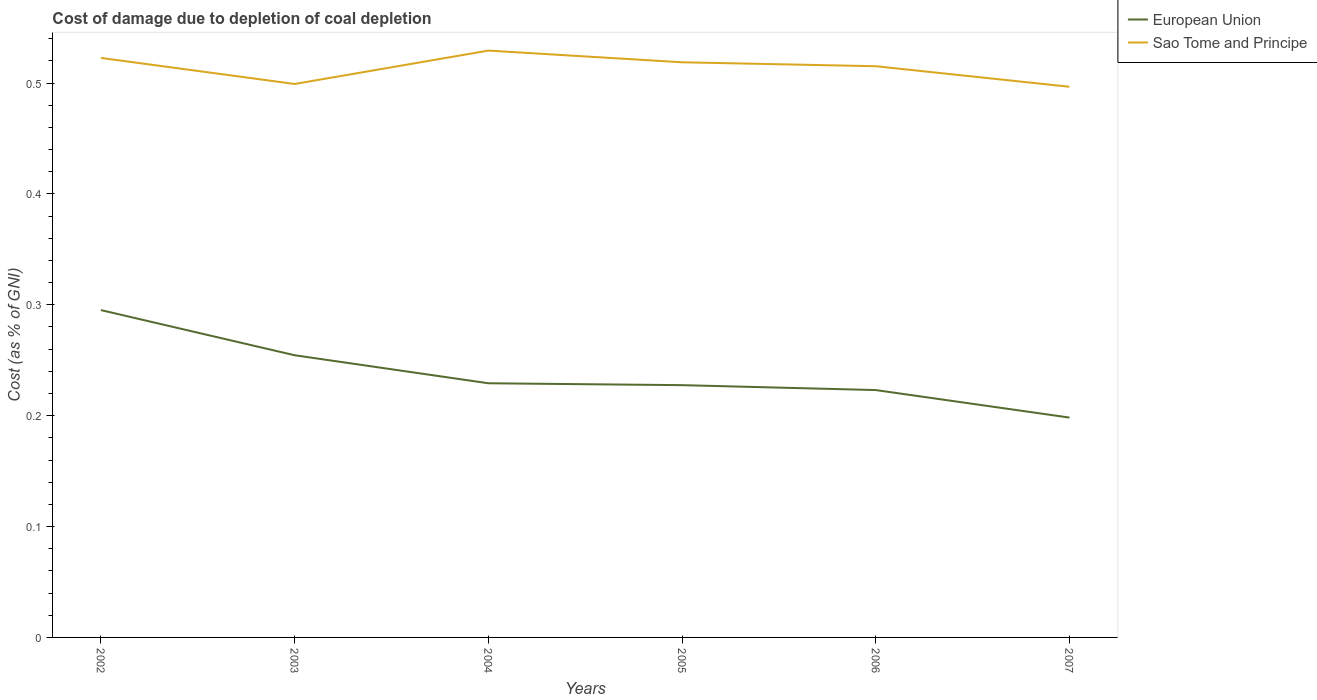Does the line corresponding to Sao Tome and Principe intersect with the line corresponding to European Union?
Your answer should be very brief. No. Is the number of lines equal to the number of legend labels?
Offer a terse response. Yes. Across all years, what is the maximum cost of damage caused due to coal depletion in Sao Tome and Principe?
Provide a succinct answer. 0.5. In which year was the cost of damage caused due to coal depletion in European Union maximum?
Keep it short and to the point. 2007. What is the total cost of damage caused due to coal depletion in European Union in the graph?
Ensure brevity in your answer.  0.04. What is the difference between the highest and the second highest cost of damage caused due to coal depletion in Sao Tome and Principe?
Make the answer very short. 0.03. What is the difference between the highest and the lowest cost of damage caused due to coal depletion in European Union?
Keep it short and to the point. 2. How many lines are there?
Offer a very short reply. 2. Does the graph contain grids?
Make the answer very short. No. Where does the legend appear in the graph?
Your response must be concise. Top right. How many legend labels are there?
Keep it short and to the point. 2. What is the title of the graph?
Keep it short and to the point. Cost of damage due to depletion of coal depletion. Does "Yemen, Rep." appear as one of the legend labels in the graph?
Offer a terse response. No. What is the label or title of the X-axis?
Give a very brief answer. Years. What is the label or title of the Y-axis?
Your answer should be very brief. Cost (as % of GNI). What is the Cost (as % of GNI) in European Union in 2002?
Your answer should be compact. 0.3. What is the Cost (as % of GNI) of Sao Tome and Principe in 2002?
Your response must be concise. 0.52. What is the Cost (as % of GNI) of European Union in 2003?
Your response must be concise. 0.25. What is the Cost (as % of GNI) of Sao Tome and Principe in 2003?
Offer a very short reply. 0.5. What is the Cost (as % of GNI) of European Union in 2004?
Give a very brief answer. 0.23. What is the Cost (as % of GNI) of Sao Tome and Principe in 2004?
Your answer should be very brief. 0.53. What is the Cost (as % of GNI) in European Union in 2005?
Offer a very short reply. 0.23. What is the Cost (as % of GNI) of Sao Tome and Principe in 2005?
Provide a succinct answer. 0.52. What is the Cost (as % of GNI) of European Union in 2006?
Make the answer very short. 0.22. What is the Cost (as % of GNI) of Sao Tome and Principe in 2006?
Keep it short and to the point. 0.52. What is the Cost (as % of GNI) of European Union in 2007?
Offer a terse response. 0.2. What is the Cost (as % of GNI) in Sao Tome and Principe in 2007?
Offer a very short reply. 0.5. Across all years, what is the maximum Cost (as % of GNI) of European Union?
Your response must be concise. 0.3. Across all years, what is the maximum Cost (as % of GNI) of Sao Tome and Principe?
Your answer should be very brief. 0.53. Across all years, what is the minimum Cost (as % of GNI) in European Union?
Your answer should be compact. 0.2. Across all years, what is the minimum Cost (as % of GNI) of Sao Tome and Principe?
Your answer should be very brief. 0.5. What is the total Cost (as % of GNI) in European Union in the graph?
Keep it short and to the point. 1.43. What is the total Cost (as % of GNI) in Sao Tome and Principe in the graph?
Offer a terse response. 3.08. What is the difference between the Cost (as % of GNI) of European Union in 2002 and that in 2003?
Give a very brief answer. 0.04. What is the difference between the Cost (as % of GNI) in Sao Tome and Principe in 2002 and that in 2003?
Offer a terse response. 0.02. What is the difference between the Cost (as % of GNI) of European Union in 2002 and that in 2004?
Your response must be concise. 0.07. What is the difference between the Cost (as % of GNI) of Sao Tome and Principe in 2002 and that in 2004?
Offer a terse response. -0.01. What is the difference between the Cost (as % of GNI) of European Union in 2002 and that in 2005?
Ensure brevity in your answer.  0.07. What is the difference between the Cost (as % of GNI) of Sao Tome and Principe in 2002 and that in 2005?
Your answer should be very brief. 0. What is the difference between the Cost (as % of GNI) of European Union in 2002 and that in 2006?
Give a very brief answer. 0.07. What is the difference between the Cost (as % of GNI) in Sao Tome and Principe in 2002 and that in 2006?
Make the answer very short. 0.01. What is the difference between the Cost (as % of GNI) in European Union in 2002 and that in 2007?
Ensure brevity in your answer.  0.1. What is the difference between the Cost (as % of GNI) of Sao Tome and Principe in 2002 and that in 2007?
Your response must be concise. 0.03. What is the difference between the Cost (as % of GNI) in European Union in 2003 and that in 2004?
Offer a terse response. 0.03. What is the difference between the Cost (as % of GNI) of Sao Tome and Principe in 2003 and that in 2004?
Provide a short and direct response. -0.03. What is the difference between the Cost (as % of GNI) of European Union in 2003 and that in 2005?
Provide a short and direct response. 0.03. What is the difference between the Cost (as % of GNI) in Sao Tome and Principe in 2003 and that in 2005?
Offer a very short reply. -0.02. What is the difference between the Cost (as % of GNI) in European Union in 2003 and that in 2006?
Provide a short and direct response. 0.03. What is the difference between the Cost (as % of GNI) of Sao Tome and Principe in 2003 and that in 2006?
Offer a very short reply. -0.02. What is the difference between the Cost (as % of GNI) of European Union in 2003 and that in 2007?
Give a very brief answer. 0.06. What is the difference between the Cost (as % of GNI) in Sao Tome and Principe in 2003 and that in 2007?
Give a very brief answer. 0. What is the difference between the Cost (as % of GNI) of European Union in 2004 and that in 2005?
Give a very brief answer. 0. What is the difference between the Cost (as % of GNI) of Sao Tome and Principe in 2004 and that in 2005?
Offer a terse response. 0.01. What is the difference between the Cost (as % of GNI) of European Union in 2004 and that in 2006?
Offer a very short reply. 0.01. What is the difference between the Cost (as % of GNI) in Sao Tome and Principe in 2004 and that in 2006?
Keep it short and to the point. 0.01. What is the difference between the Cost (as % of GNI) in European Union in 2004 and that in 2007?
Make the answer very short. 0.03. What is the difference between the Cost (as % of GNI) of Sao Tome and Principe in 2004 and that in 2007?
Give a very brief answer. 0.03. What is the difference between the Cost (as % of GNI) in European Union in 2005 and that in 2006?
Offer a very short reply. 0. What is the difference between the Cost (as % of GNI) in Sao Tome and Principe in 2005 and that in 2006?
Keep it short and to the point. 0. What is the difference between the Cost (as % of GNI) of European Union in 2005 and that in 2007?
Provide a succinct answer. 0.03. What is the difference between the Cost (as % of GNI) of Sao Tome and Principe in 2005 and that in 2007?
Provide a short and direct response. 0.02. What is the difference between the Cost (as % of GNI) of European Union in 2006 and that in 2007?
Keep it short and to the point. 0.02. What is the difference between the Cost (as % of GNI) of Sao Tome and Principe in 2006 and that in 2007?
Give a very brief answer. 0.02. What is the difference between the Cost (as % of GNI) in European Union in 2002 and the Cost (as % of GNI) in Sao Tome and Principe in 2003?
Give a very brief answer. -0.2. What is the difference between the Cost (as % of GNI) in European Union in 2002 and the Cost (as % of GNI) in Sao Tome and Principe in 2004?
Your answer should be compact. -0.23. What is the difference between the Cost (as % of GNI) of European Union in 2002 and the Cost (as % of GNI) of Sao Tome and Principe in 2005?
Make the answer very short. -0.22. What is the difference between the Cost (as % of GNI) in European Union in 2002 and the Cost (as % of GNI) in Sao Tome and Principe in 2006?
Ensure brevity in your answer.  -0.22. What is the difference between the Cost (as % of GNI) in European Union in 2002 and the Cost (as % of GNI) in Sao Tome and Principe in 2007?
Your response must be concise. -0.2. What is the difference between the Cost (as % of GNI) of European Union in 2003 and the Cost (as % of GNI) of Sao Tome and Principe in 2004?
Your answer should be compact. -0.27. What is the difference between the Cost (as % of GNI) of European Union in 2003 and the Cost (as % of GNI) of Sao Tome and Principe in 2005?
Your answer should be compact. -0.26. What is the difference between the Cost (as % of GNI) of European Union in 2003 and the Cost (as % of GNI) of Sao Tome and Principe in 2006?
Provide a succinct answer. -0.26. What is the difference between the Cost (as % of GNI) in European Union in 2003 and the Cost (as % of GNI) in Sao Tome and Principe in 2007?
Keep it short and to the point. -0.24. What is the difference between the Cost (as % of GNI) of European Union in 2004 and the Cost (as % of GNI) of Sao Tome and Principe in 2005?
Give a very brief answer. -0.29. What is the difference between the Cost (as % of GNI) in European Union in 2004 and the Cost (as % of GNI) in Sao Tome and Principe in 2006?
Give a very brief answer. -0.29. What is the difference between the Cost (as % of GNI) in European Union in 2004 and the Cost (as % of GNI) in Sao Tome and Principe in 2007?
Offer a very short reply. -0.27. What is the difference between the Cost (as % of GNI) of European Union in 2005 and the Cost (as % of GNI) of Sao Tome and Principe in 2006?
Provide a short and direct response. -0.29. What is the difference between the Cost (as % of GNI) of European Union in 2005 and the Cost (as % of GNI) of Sao Tome and Principe in 2007?
Provide a succinct answer. -0.27. What is the difference between the Cost (as % of GNI) of European Union in 2006 and the Cost (as % of GNI) of Sao Tome and Principe in 2007?
Keep it short and to the point. -0.27. What is the average Cost (as % of GNI) in European Union per year?
Offer a very short reply. 0.24. What is the average Cost (as % of GNI) of Sao Tome and Principe per year?
Your answer should be very brief. 0.51. In the year 2002, what is the difference between the Cost (as % of GNI) in European Union and Cost (as % of GNI) in Sao Tome and Principe?
Keep it short and to the point. -0.23. In the year 2003, what is the difference between the Cost (as % of GNI) of European Union and Cost (as % of GNI) of Sao Tome and Principe?
Keep it short and to the point. -0.24. In the year 2005, what is the difference between the Cost (as % of GNI) of European Union and Cost (as % of GNI) of Sao Tome and Principe?
Give a very brief answer. -0.29. In the year 2006, what is the difference between the Cost (as % of GNI) of European Union and Cost (as % of GNI) of Sao Tome and Principe?
Give a very brief answer. -0.29. In the year 2007, what is the difference between the Cost (as % of GNI) of European Union and Cost (as % of GNI) of Sao Tome and Principe?
Your response must be concise. -0.3. What is the ratio of the Cost (as % of GNI) of European Union in 2002 to that in 2003?
Your response must be concise. 1.16. What is the ratio of the Cost (as % of GNI) in Sao Tome and Principe in 2002 to that in 2003?
Give a very brief answer. 1.05. What is the ratio of the Cost (as % of GNI) of European Union in 2002 to that in 2004?
Your answer should be very brief. 1.29. What is the ratio of the Cost (as % of GNI) in Sao Tome and Principe in 2002 to that in 2004?
Your answer should be compact. 0.99. What is the ratio of the Cost (as % of GNI) in European Union in 2002 to that in 2005?
Your response must be concise. 1.3. What is the ratio of the Cost (as % of GNI) in Sao Tome and Principe in 2002 to that in 2005?
Keep it short and to the point. 1.01. What is the ratio of the Cost (as % of GNI) in European Union in 2002 to that in 2006?
Your response must be concise. 1.32. What is the ratio of the Cost (as % of GNI) in Sao Tome and Principe in 2002 to that in 2006?
Give a very brief answer. 1.01. What is the ratio of the Cost (as % of GNI) of European Union in 2002 to that in 2007?
Your answer should be very brief. 1.49. What is the ratio of the Cost (as % of GNI) in Sao Tome and Principe in 2002 to that in 2007?
Provide a short and direct response. 1.05. What is the ratio of the Cost (as % of GNI) of European Union in 2003 to that in 2004?
Provide a short and direct response. 1.11. What is the ratio of the Cost (as % of GNI) in Sao Tome and Principe in 2003 to that in 2004?
Offer a terse response. 0.94. What is the ratio of the Cost (as % of GNI) of European Union in 2003 to that in 2005?
Offer a terse response. 1.12. What is the ratio of the Cost (as % of GNI) of Sao Tome and Principe in 2003 to that in 2005?
Keep it short and to the point. 0.96. What is the ratio of the Cost (as % of GNI) in European Union in 2003 to that in 2006?
Your answer should be very brief. 1.14. What is the ratio of the Cost (as % of GNI) in Sao Tome and Principe in 2003 to that in 2006?
Offer a terse response. 0.97. What is the ratio of the Cost (as % of GNI) in European Union in 2003 to that in 2007?
Your answer should be very brief. 1.28. What is the ratio of the Cost (as % of GNI) of European Union in 2004 to that in 2005?
Offer a terse response. 1.01. What is the ratio of the Cost (as % of GNI) in Sao Tome and Principe in 2004 to that in 2005?
Ensure brevity in your answer.  1.02. What is the ratio of the Cost (as % of GNI) of European Union in 2004 to that in 2006?
Provide a succinct answer. 1.03. What is the ratio of the Cost (as % of GNI) of Sao Tome and Principe in 2004 to that in 2006?
Your response must be concise. 1.03. What is the ratio of the Cost (as % of GNI) of European Union in 2004 to that in 2007?
Offer a very short reply. 1.16. What is the ratio of the Cost (as % of GNI) of Sao Tome and Principe in 2004 to that in 2007?
Your answer should be compact. 1.07. What is the ratio of the Cost (as % of GNI) of European Union in 2005 to that in 2006?
Provide a short and direct response. 1.02. What is the ratio of the Cost (as % of GNI) in European Union in 2005 to that in 2007?
Make the answer very short. 1.15. What is the ratio of the Cost (as % of GNI) in Sao Tome and Principe in 2005 to that in 2007?
Your response must be concise. 1.04. What is the ratio of the Cost (as % of GNI) in European Union in 2006 to that in 2007?
Offer a very short reply. 1.13. What is the ratio of the Cost (as % of GNI) in Sao Tome and Principe in 2006 to that in 2007?
Offer a very short reply. 1.04. What is the difference between the highest and the second highest Cost (as % of GNI) in European Union?
Your response must be concise. 0.04. What is the difference between the highest and the second highest Cost (as % of GNI) in Sao Tome and Principe?
Your response must be concise. 0.01. What is the difference between the highest and the lowest Cost (as % of GNI) in European Union?
Offer a very short reply. 0.1. What is the difference between the highest and the lowest Cost (as % of GNI) of Sao Tome and Principe?
Keep it short and to the point. 0.03. 